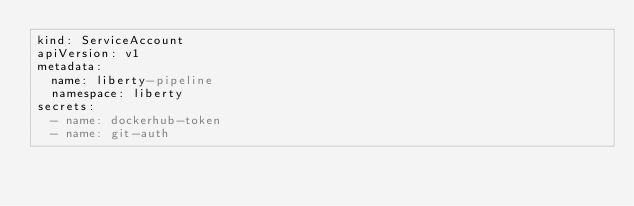<code> <loc_0><loc_0><loc_500><loc_500><_YAML_>kind: ServiceAccount
apiVersion: v1
metadata:
  name: liberty-pipeline
  namespace: liberty
secrets:
  - name: dockerhub-token
  - name: git-auth
</code> 